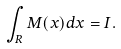<formula> <loc_0><loc_0><loc_500><loc_500>\int _ { R } M ( x ) d x = I .</formula> 